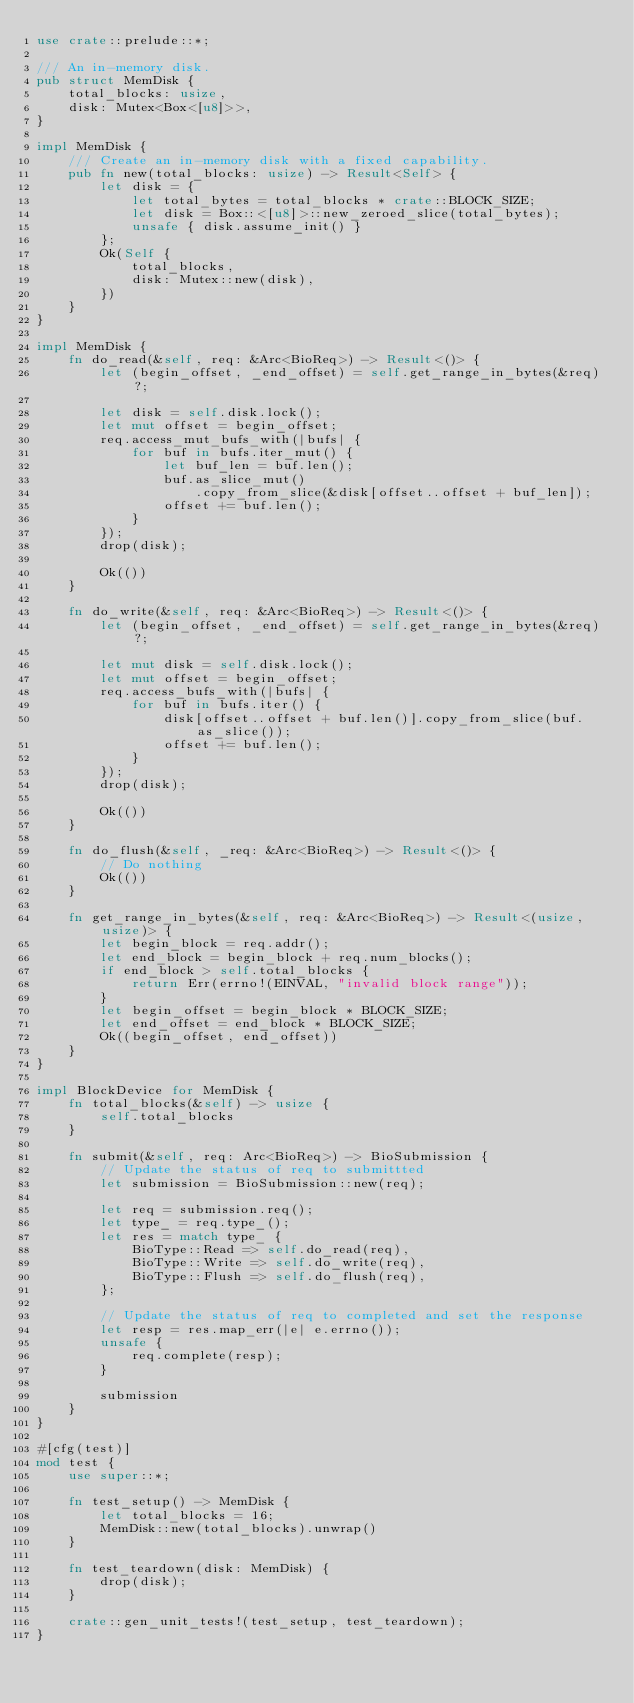<code> <loc_0><loc_0><loc_500><loc_500><_Rust_>use crate::prelude::*;

/// An in-memory disk.
pub struct MemDisk {
    total_blocks: usize,
    disk: Mutex<Box<[u8]>>,
}

impl MemDisk {
    /// Create an in-memory disk with a fixed capability.
    pub fn new(total_blocks: usize) -> Result<Self> {
        let disk = {
            let total_bytes = total_blocks * crate::BLOCK_SIZE;
            let disk = Box::<[u8]>::new_zeroed_slice(total_bytes);
            unsafe { disk.assume_init() }
        };
        Ok(Self {
            total_blocks,
            disk: Mutex::new(disk),
        })
    }
}

impl MemDisk {
    fn do_read(&self, req: &Arc<BioReq>) -> Result<()> {
        let (begin_offset, _end_offset) = self.get_range_in_bytes(&req)?;

        let disk = self.disk.lock();
        let mut offset = begin_offset;
        req.access_mut_bufs_with(|bufs| {
            for buf in bufs.iter_mut() {
                let buf_len = buf.len();
                buf.as_slice_mut()
                    .copy_from_slice(&disk[offset..offset + buf_len]);
                offset += buf.len();
            }
        });
        drop(disk);

        Ok(())
    }

    fn do_write(&self, req: &Arc<BioReq>) -> Result<()> {
        let (begin_offset, _end_offset) = self.get_range_in_bytes(&req)?;

        let mut disk = self.disk.lock();
        let mut offset = begin_offset;
        req.access_bufs_with(|bufs| {
            for buf in bufs.iter() {
                disk[offset..offset + buf.len()].copy_from_slice(buf.as_slice());
                offset += buf.len();
            }
        });
        drop(disk);

        Ok(())
    }

    fn do_flush(&self, _req: &Arc<BioReq>) -> Result<()> {
        // Do nothing
        Ok(())
    }

    fn get_range_in_bytes(&self, req: &Arc<BioReq>) -> Result<(usize, usize)> {
        let begin_block = req.addr();
        let end_block = begin_block + req.num_blocks();
        if end_block > self.total_blocks {
            return Err(errno!(EINVAL, "invalid block range"));
        }
        let begin_offset = begin_block * BLOCK_SIZE;
        let end_offset = end_block * BLOCK_SIZE;
        Ok((begin_offset, end_offset))
    }
}

impl BlockDevice for MemDisk {
    fn total_blocks(&self) -> usize {
        self.total_blocks
    }

    fn submit(&self, req: Arc<BioReq>) -> BioSubmission {
        // Update the status of req to submittted
        let submission = BioSubmission::new(req);

        let req = submission.req();
        let type_ = req.type_();
        let res = match type_ {
            BioType::Read => self.do_read(req),
            BioType::Write => self.do_write(req),
            BioType::Flush => self.do_flush(req),
        };

        // Update the status of req to completed and set the response
        let resp = res.map_err(|e| e.errno());
        unsafe {
            req.complete(resp);
        }

        submission
    }
}

#[cfg(test)]
mod test {
    use super::*;

    fn test_setup() -> MemDisk {
        let total_blocks = 16;
        MemDisk::new(total_blocks).unwrap()
    }

    fn test_teardown(disk: MemDisk) {
        drop(disk);
    }

    crate::gen_unit_tests!(test_setup, test_teardown);
}
</code> 